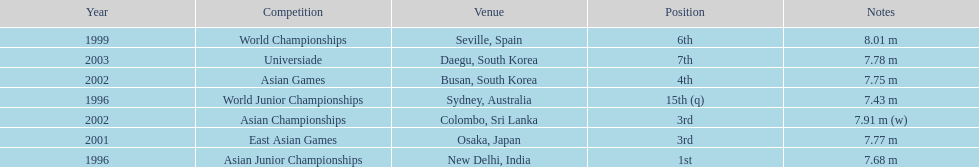How many times did his jump surpass 7.70 m? 5. 